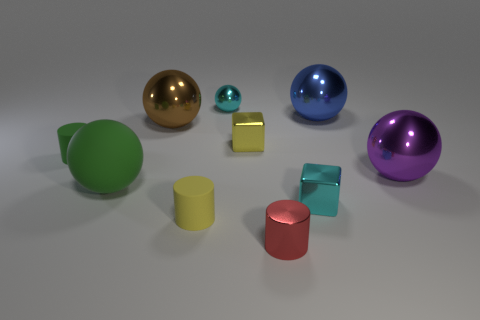Do the metal block in front of the purple shiny thing and the small sphere have the same color?
Your answer should be compact. Yes. Do the shiny block to the right of the small yellow metallic cube and the tiny metallic object that is behind the brown thing have the same color?
Ensure brevity in your answer.  Yes. What material is the small cylinder that is the same color as the large matte sphere?
Provide a short and direct response. Rubber. Is there a small matte thing that has the same color as the big matte object?
Keep it short and to the point. Yes. Is the number of tiny green things that are in front of the yellow shiny cube less than the number of small green things?
Your response must be concise. No. What number of metal balls are there?
Keep it short and to the point. 4. How many other cyan balls have the same material as the cyan ball?
Offer a terse response. 0. What number of things are either things to the left of the cyan cube or big blue shiny balls?
Make the answer very short. 8. Are there fewer green spheres on the left side of the small green matte cylinder than large things that are behind the green sphere?
Your answer should be very brief. Yes. There is a blue metallic sphere; are there any brown balls left of it?
Give a very brief answer. Yes. 